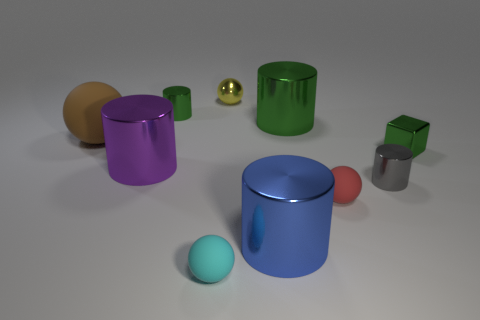Subtract 2 cylinders. How many cylinders are left? 3 Subtract all purple cylinders. How many cylinders are left? 4 Subtract all blue cylinders. How many cylinders are left? 4 Subtract all yellow cylinders. Subtract all brown cubes. How many cylinders are left? 5 Subtract all spheres. How many objects are left? 6 Subtract all big green metallic objects. Subtract all blue shiny cylinders. How many objects are left? 8 Add 6 gray objects. How many gray objects are left? 7 Add 1 brown shiny cubes. How many brown shiny cubes exist? 1 Subtract 1 purple cylinders. How many objects are left? 9 